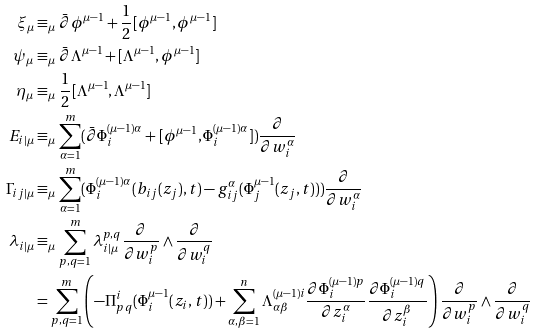Convert formula to latex. <formula><loc_0><loc_0><loc_500><loc_500>\xi _ { \mu } & \equiv _ { \mu } \bar { \partial } \phi ^ { \mu - 1 } + \frac { 1 } { 2 } [ \phi ^ { \mu - 1 } , \phi ^ { \mu - 1 } ] \\ \psi _ { \mu } & \equiv _ { \mu } \bar { \partial } \Lambda ^ { \mu - 1 } + [ \Lambda ^ { \mu - 1 } , \phi ^ { \mu - 1 } ] \\ \eta _ { \mu } & \equiv _ { \mu } \frac { 1 } { 2 } [ \Lambda ^ { \mu - 1 } , \Lambda ^ { \mu - 1 } ] \\ E _ { i | \mu } & \equiv _ { \mu } \sum _ { \alpha = 1 } ^ { m } ( \bar { \partial } \Phi _ { i } ^ { ( \mu - 1 ) \alpha } + [ \phi ^ { \mu - 1 } , \Phi _ { i } ^ { ( \mu - 1 ) \alpha } ] ) \frac { \partial } { \partial w _ { i } ^ { \alpha } } \\ \Gamma _ { i j | \mu } & \equiv _ { \mu } \sum _ { \alpha = 1 } ^ { m } ( \Phi _ { i } ^ { ( \mu - 1 ) \alpha } ( b _ { i j } ( z _ { j } ) , t ) - g _ { i j } ^ { \alpha } ( \Phi _ { j } ^ { \mu - 1 } ( z _ { j } , t ) ) ) \frac { \partial } { \partial w _ { i } ^ { \alpha } } \\ \lambda _ { i | \mu } & \equiv _ { \mu } \sum _ { p , q = 1 } ^ { m } \lambda _ { i | \mu } ^ { p , q } \frac { \partial } { \partial w _ { i } ^ { p } } \wedge \frac { \partial } { \partial w _ { i } ^ { q } } \\ & = \sum _ { p , q = 1 } ^ { m } \left ( - \Pi _ { p q } ^ { i } ( \Phi _ { i } ^ { \mu - 1 } ( z _ { i } , t ) ) + \sum _ { \alpha , \beta = 1 } ^ { n } \Lambda _ { \alpha \beta } ^ { ( \mu - 1 ) i } \frac { \partial \Phi _ { i } ^ { ( \mu - 1 ) p } } { \partial z _ { i } ^ { \alpha } } \frac { \partial \Phi _ { i } ^ { ( \mu - 1 ) q } } { \partial z _ { i } ^ { \beta } } \right ) \frac { \partial } { \partial w _ { i } ^ { p } } \wedge \frac { \partial } { \partial w _ { i } ^ { q } }</formula> 